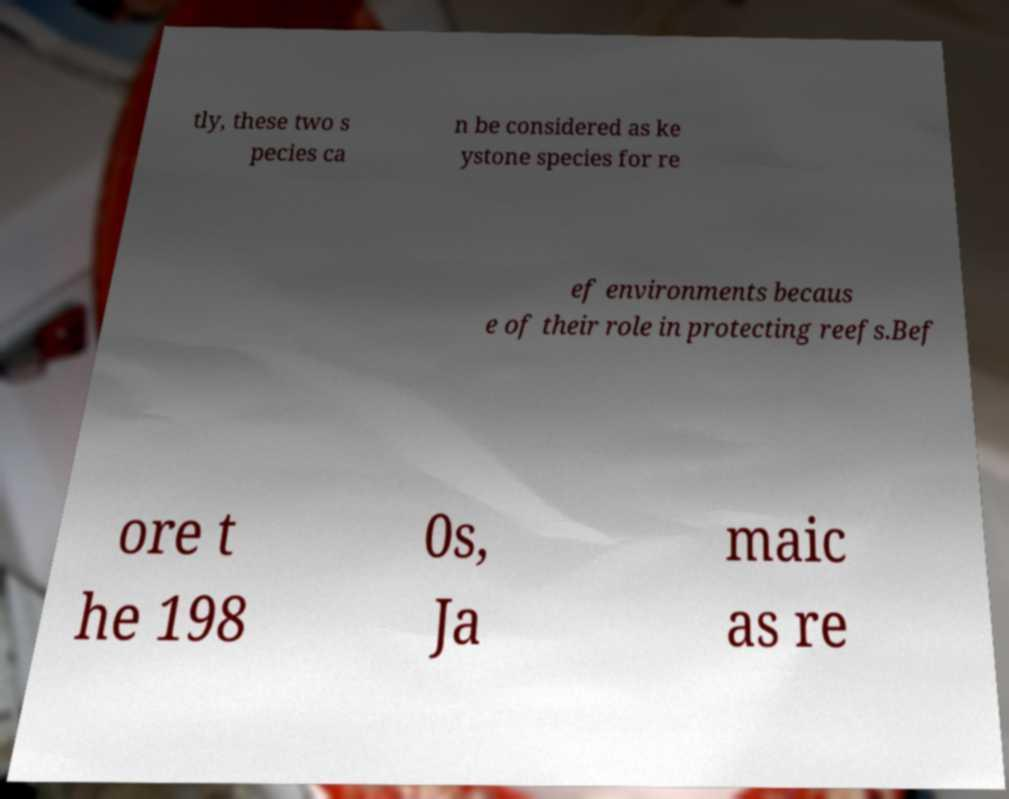Could you assist in decoding the text presented in this image and type it out clearly? tly, these two s pecies ca n be considered as ke ystone species for re ef environments becaus e of their role in protecting reefs.Bef ore t he 198 0s, Ja maic as re 